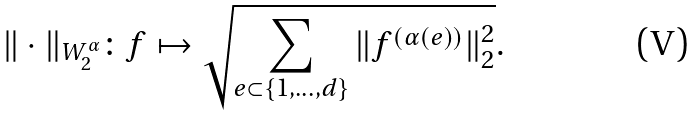<formula> <loc_0><loc_0><loc_500><loc_500>\| \cdot \| _ { W ^ { \alpha } _ { 2 } } \colon f \mapsto \sqrt { \sum _ { e \subset \{ 1 , \dots , d \} } \| f ^ { ( \alpha ( e ) ) } \| _ { 2 } ^ { 2 } } .</formula> 